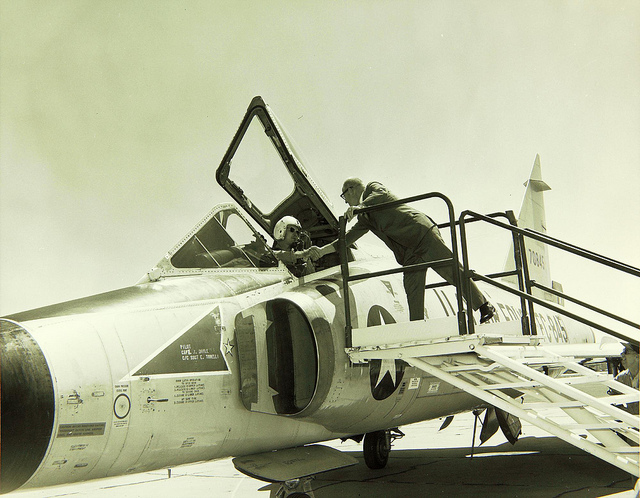Identify the text displayed in this image. 845 